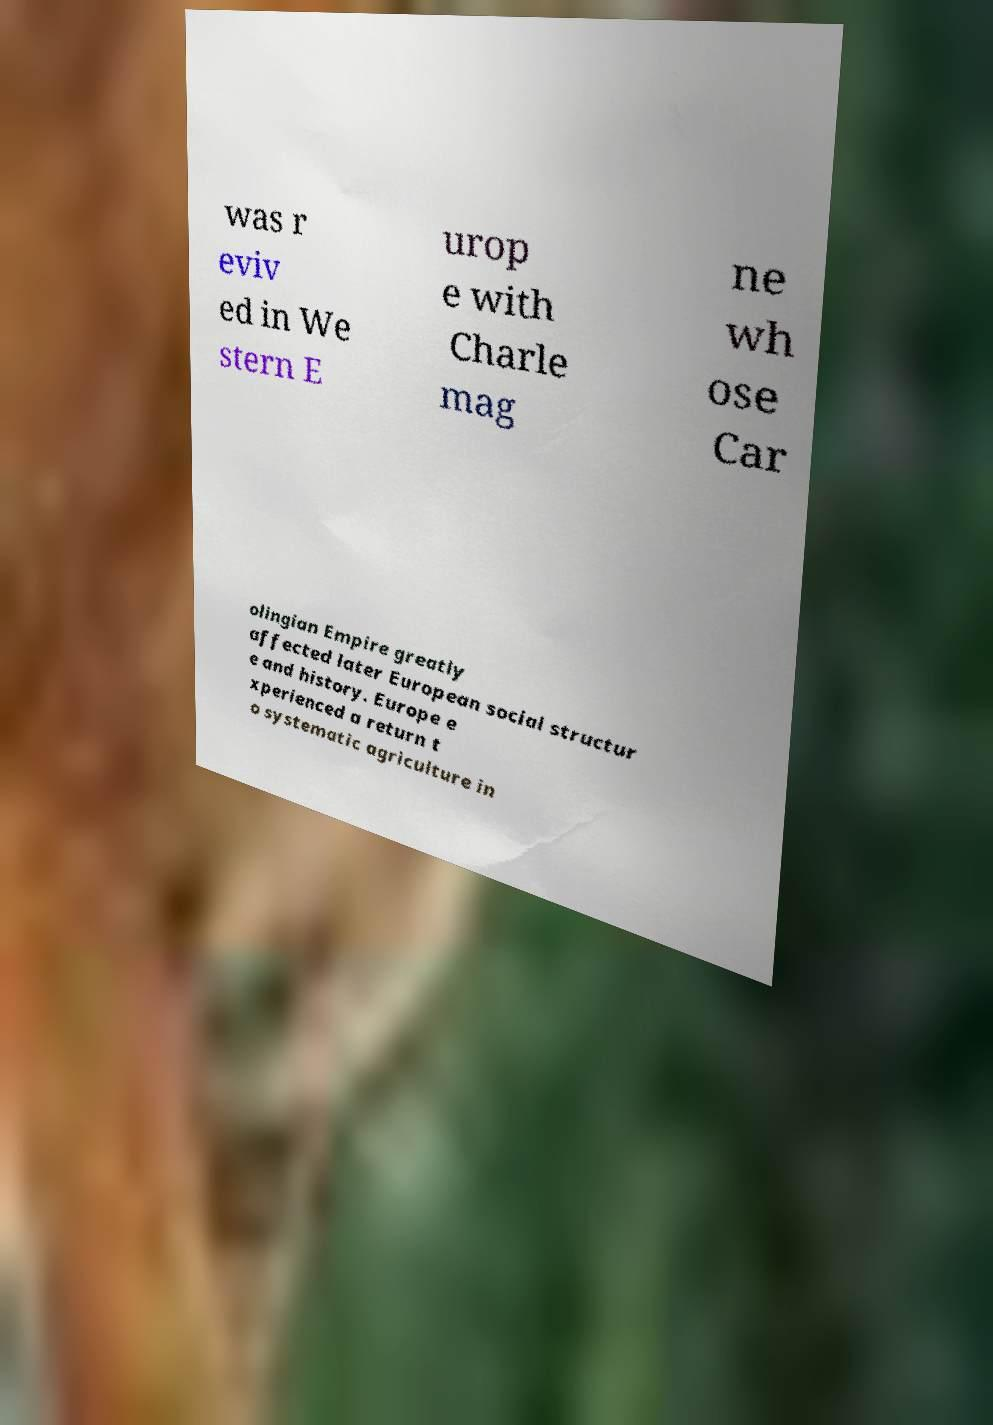Please read and relay the text visible in this image. What does it say? was r eviv ed in We stern E urop e with Charle mag ne wh ose Car olingian Empire greatly affected later European social structur e and history. Europe e xperienced a return t o systematic agriculture in 